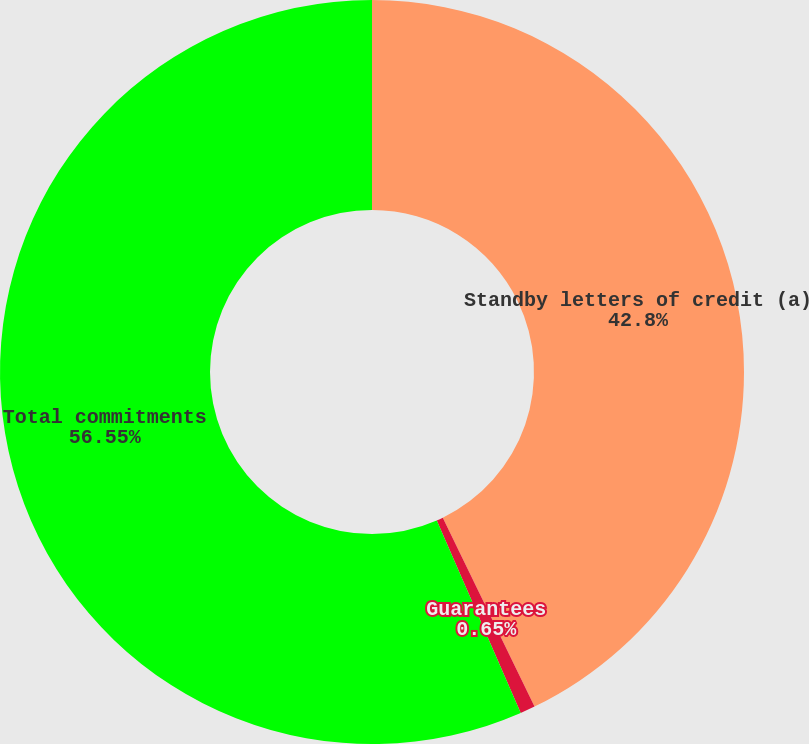Convert chart to OTSL. <chart><loc_0><loc_0><loc_500><loc_500><pie_chart><fcel>Standby letters of credit (a)<fcel>Guarantees<fcel>Total commitments<nl><fcel>42.8%<fcel>0.65%<fcel>56.54%<nl></chart> 